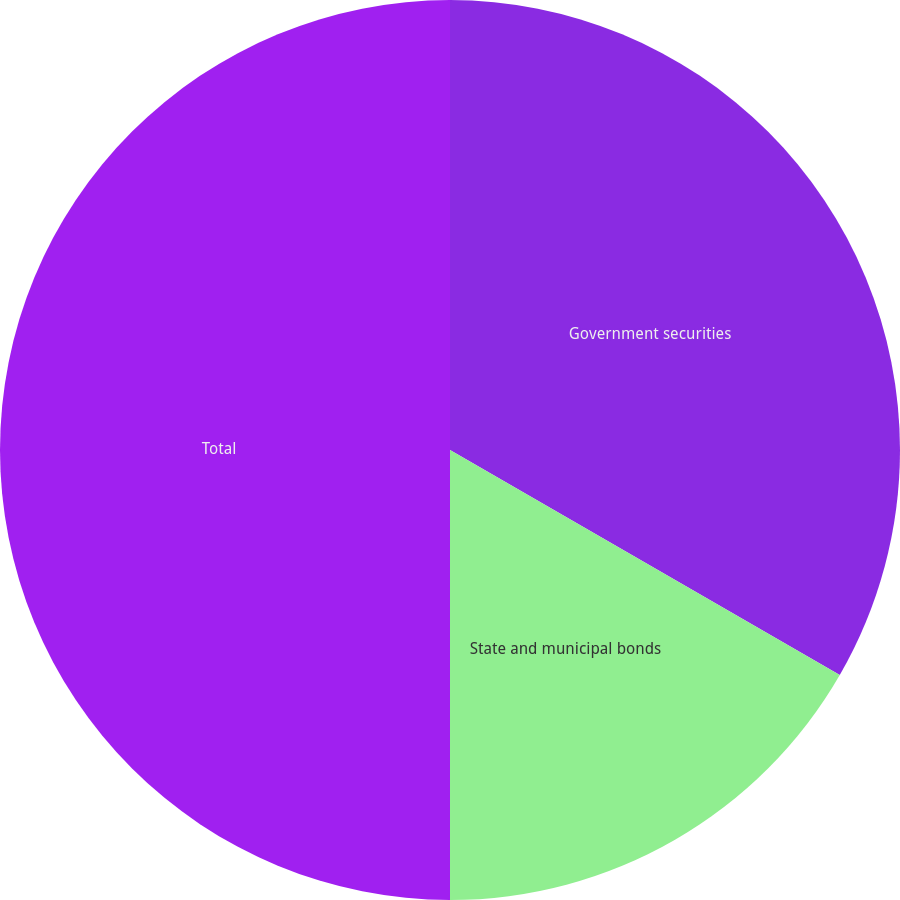<chart> <loc_0><loc_0><loc_500><loc_500><pie_chart><fcel>Government securities<fcel>State and municipal bonds<fcel>Total<nl><fcel>33.33%<fcel>16.67%<fcel>50.0%<nl></chart> 